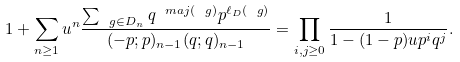Convert formula to latex. <formula><loc_0><loc_0><loc_500><loc_500>1 + \sum _ { n \geq 1 } u ^ { n } \frac { \sum _ { \ g \in D _ { n } } q ^ { \ m a j ( \ g ) } p ^ { \ell _ { D } ( \ g ) } } { ( - p ; p ) _ { n - 1 } ( q ; q ) _ { n - 1 } } = \prod _ { i , j \geq 0 } \frac { 1 } { 1 - ( 1 - p ) u p ^ { i } q ^ { j } } .</formula> 